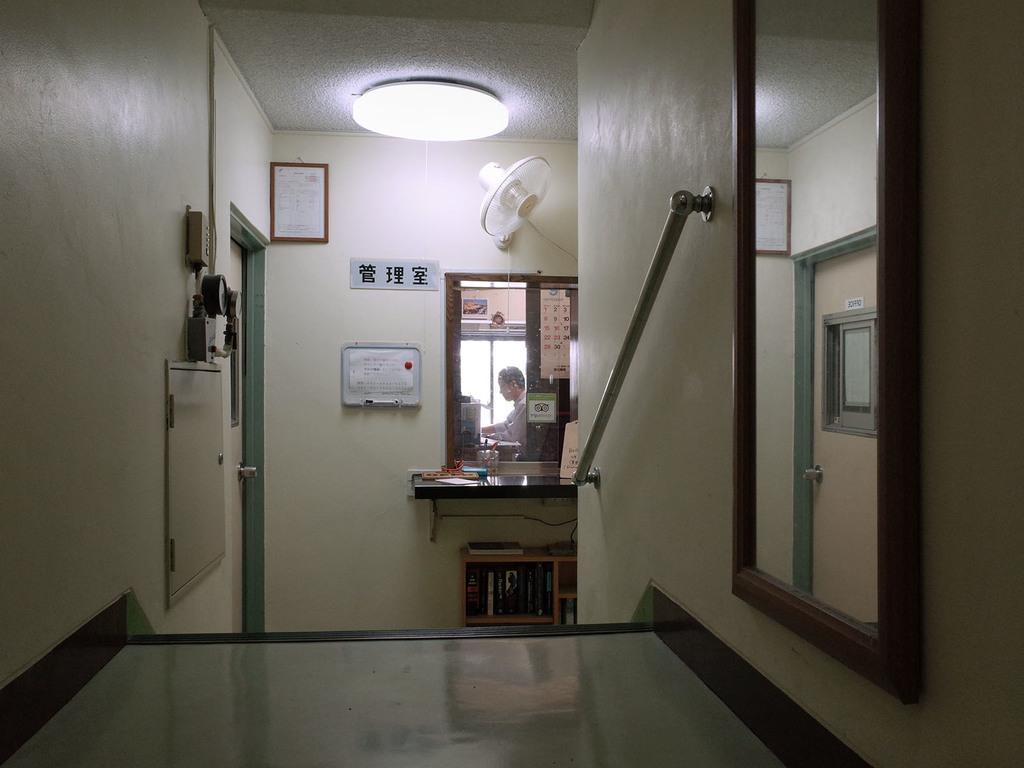Can you describe this image briefly? This image consists of a light at the top. There is a mirror in the middle. There is a mirror on the right side. There is a frame at the top. We can see a person in the mirror. 